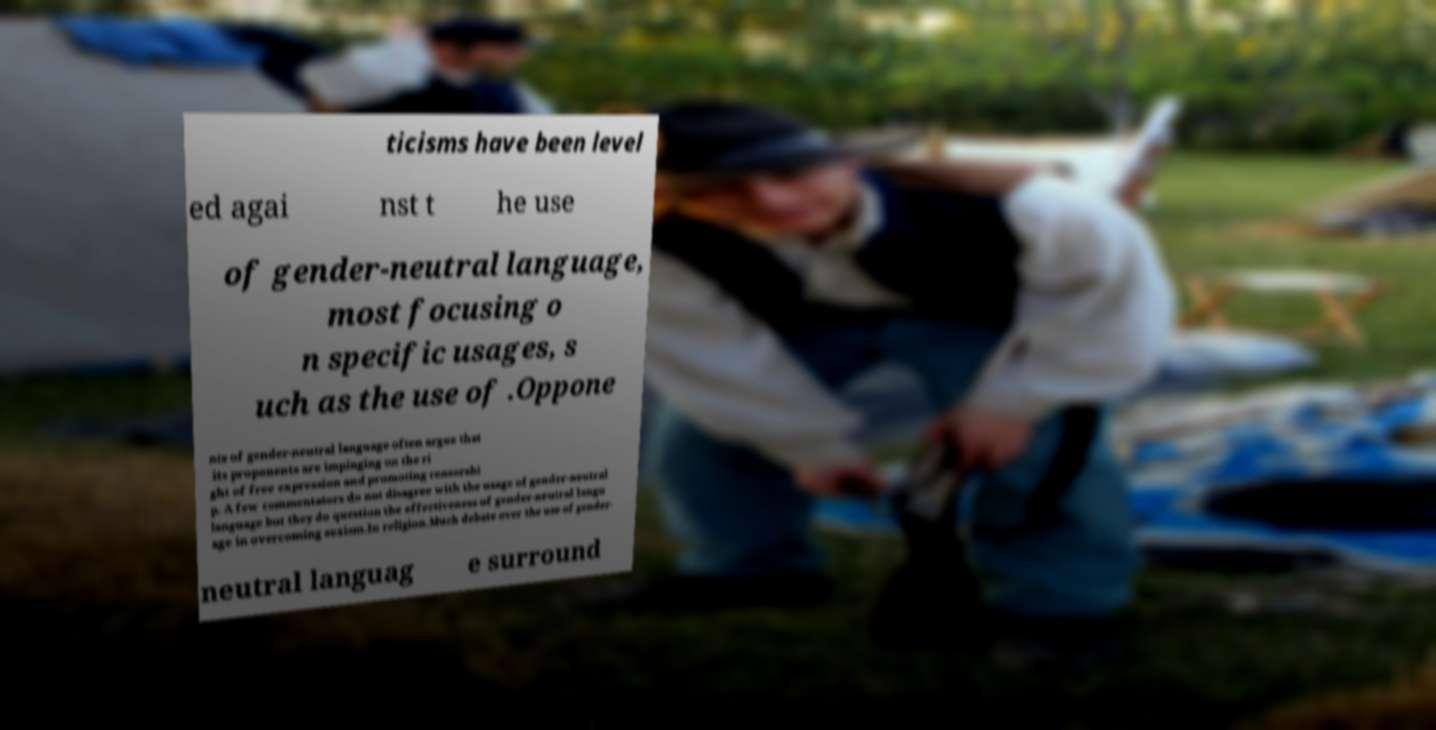Could you assist in decoding the text presented in this image and type it out clearly? ticisms have been level ed agai nst t he use of gender-neutral language, most focusing o n specific usages, s uch as the use of .Oppone nts of gender-neutral language often argue that its proponents are impinging on the ri ght of free expression and promoting censorshi p. A few commentators do not disagree with the usage of gender-neutral language but they do question the effectiveness of gender-neutral langu age in overcoming sexism.In religion.Much debate over the use of gender- neutral languag e surround 